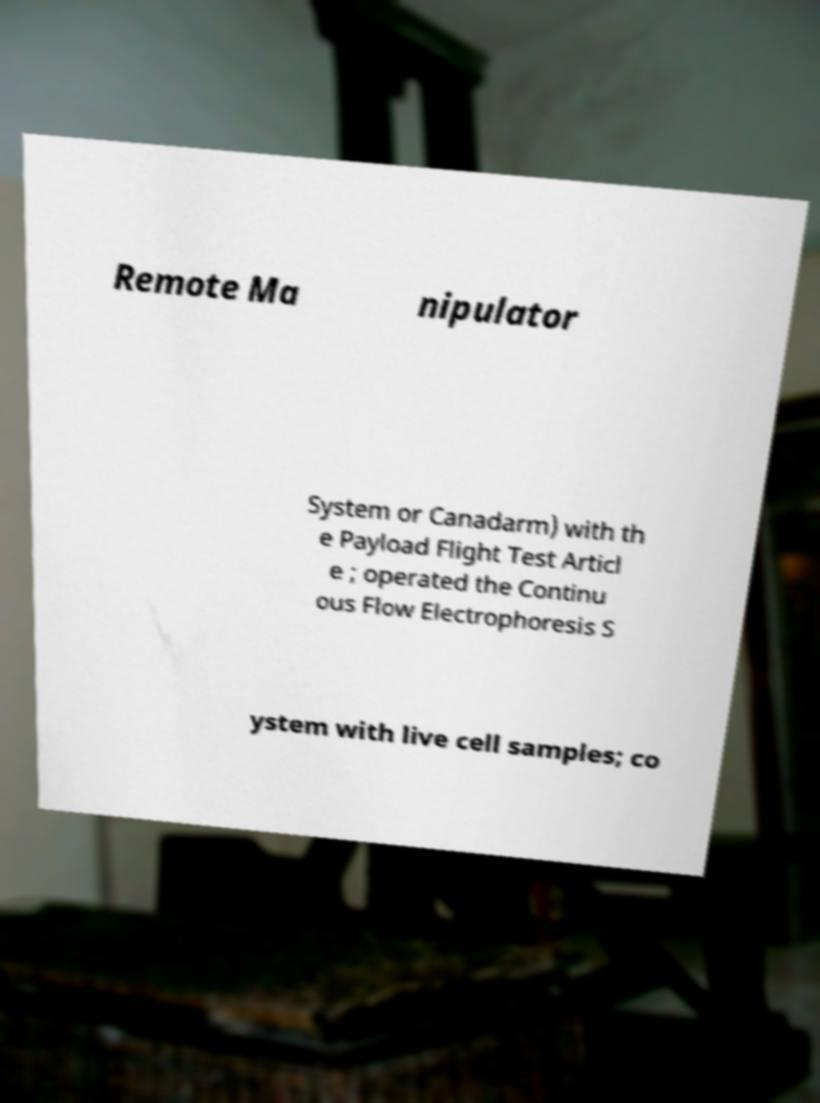For documentation purposes, I need the text within this image transcribed. Could you provide that? Remote Ma nipulator System or Canadarm) with th e Payload Flight Test Articl e ; operated the Continu ous Flow Electrophoresis S ystem with live cell samples; co 